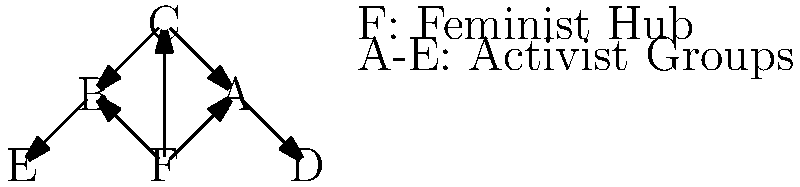Analyze the network graph representing feminist activism on social media. If the central node F represents a major feminist hub, and the surrounding nodes (A-E) represent different activist groups, how does the structure of this network impact the spread of feminist ideas and the potential for collective action? Consider concepts such as information flow, centralization, and the strength of weak ties in your analysis. 1. Network Structure:
   - The graph shows a centralized network with node F as the hub.
   - F is directly connected to nodes A, B, and C.
   - A and B are further connected to D and E, respectively.

2. Information Flow:
   - F acts as a central disseminator of information to A, B, and C.
   - A, B, and C can potentially reach D and E, extending the network's reach.
   - This structure allows for rapid dissemination of ideas from the central hub.

3. Centralization:
   - The network is highly centralized, with F playing a crucial role.
   - This centralization can lead to efficient coordination but may also create vulnerability if F is compromised.

4. Strength of Weak Ties:
   - Connections between F and A, B, C represent strong ties.
   - Links to D and E represent weak ties, potentially bringing in diverse perspectives and resources.

5. Collective Action Potential:
   - The centralized structure facilitates quick mobilization through F.
   - However, it may limit grassroots initiatives from peripheral nodes.

6. Amplification and Echo Chambers:
   - Ideas from F can be quickly amplified through the network.
   - Risk of echo chamber effect due to centralized information flow.

7. Resilience and Adaptability:
   - Network resilience depends heavily on node F.
   - Secondary connections (e.g., C to A and B) provide some redundancy.

Impact Analysis:
- Efficient for spreading core feminist messages from a central source.
- Enables rapid mobilization but may limit diversity of tactics and ideas.
- Vulnerable to censorship or disruption if the central hub is targeted.
- Potential for exponential growth through weak ties to D and E.
- Risk of oversimplification of complex feminist issues due to centralized messaging.
Answer: Centralized structure enables rapid dissemination of feminist ideas and mobilization but risks vulnerability, echo chambers, and limited grassroots input. 